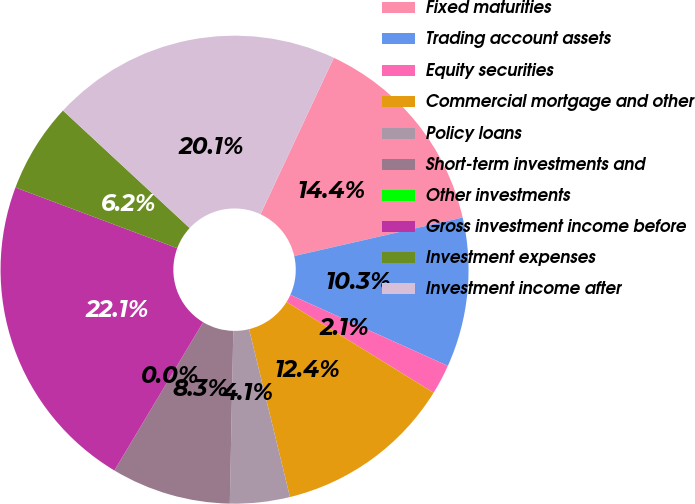Convert chart to OTSL. <chart><loc_0><loc_0><loc_500><loc_500><pie_chart><fcel>Fixed maturities<fcel>Trading account assets<fcel>Equity securities<fcel>Commercial mortgage and other<fcel>Policy loans<fcel>Short-term investments and<fcel>Other investments<fcel>Gross investment income before<fcel>Investment expenses<fcel>Investment income after<nl><fcel>14.45%<fcel>10.32%<fcel>2.07%<fcel>12.38%<fcel>4.13%<fcel>8.26%<fcel>0.0%<fcel>22.13%<fcel>6.19%<fcel>20.07%<nl></chart> 